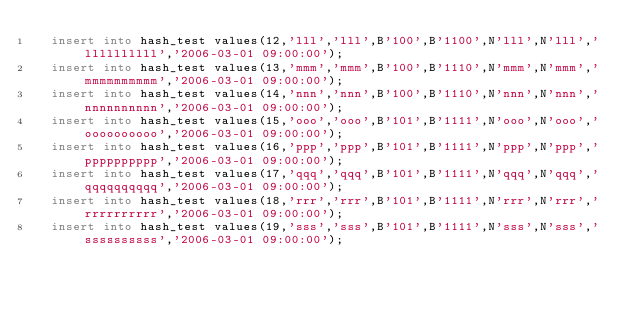<code> <loc_0><loc_0><loc_500><loc_500><_SQL_>	insert into hash_test values(12,'lll','lll',B'100',B'1100',N'lll',N'lll','llllllllll','2006-03-01 09:00:00');
	insert into hash_test values(13,'mmm','mmm',B'100',B'1110',N'mmm',N'mmm','mmmmmmmmmm','2006-03-01 09:00:00');
	insert into hash_test values(14,'nnn','nnn',B'100',B'1110',N'nnn',N'nnn','nnnnnnnnnn','2006-03-01 09:00:00');
	insert into hash_test values(15,'ooo','ooo',B'101',B'1111',N'ooo',N'ooo','oooooooooo','2006-03-01 09:00:00');
	insert into hash_test values(16,'ppp','ppp',B'101',B'1111',N'ppp',N'ppp','pppppppppp','2006-03-01 09:00:00');
	insert into hash_test values(17,'qqq','qqq',B'101',B'1111',N'qqq',N'qqq','qqqqqqqqqq','2006-03-01 09:00:00');
	insert into hash_test values(18,'rrr','rrr',B'101',B'1111',N'rrr',N'rrr','rrrrrrrrrr','2006-03-01 09:00:00');
	insert into hash_test values(19,'sss','sss',B'101',B'1111',N'sss',N'sss','ssssssssss','2006-03-01 09:00:00');</code> 